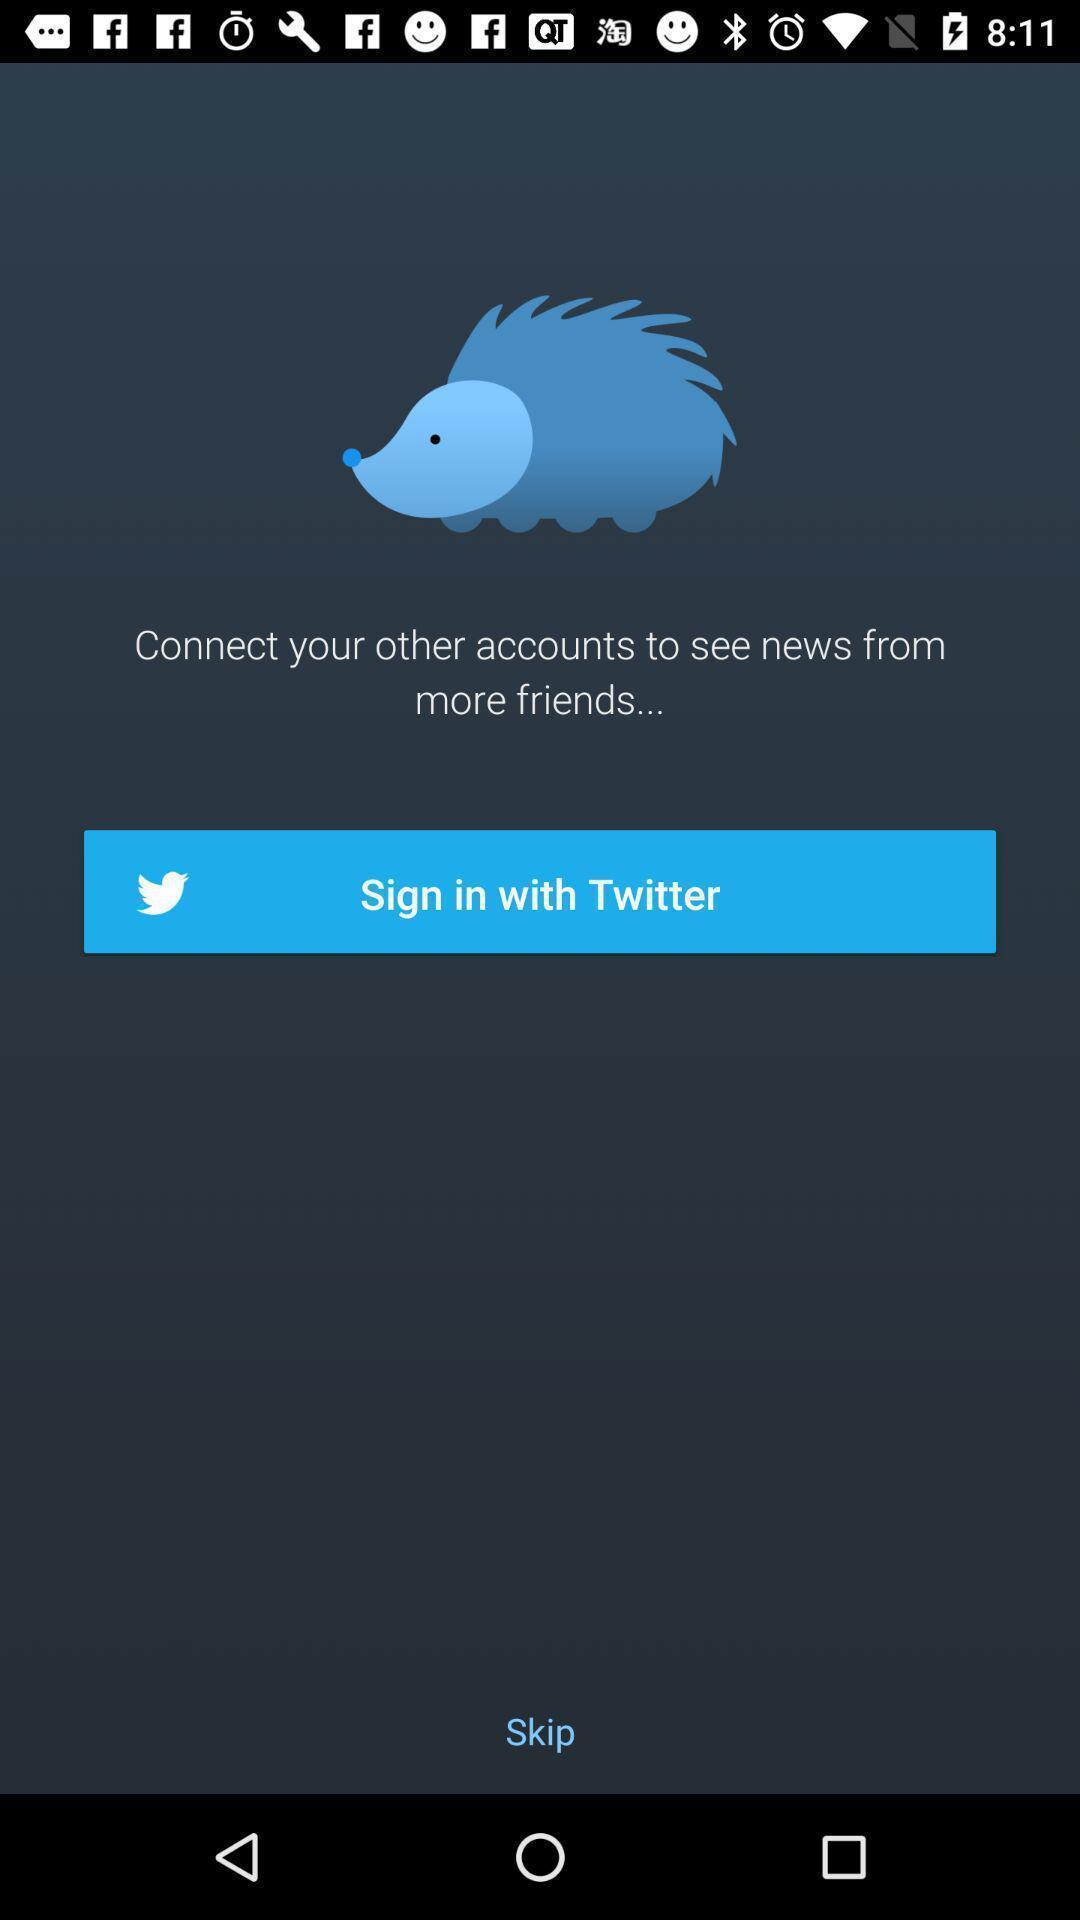Give me a summary of this screen capture. Sign in page. 